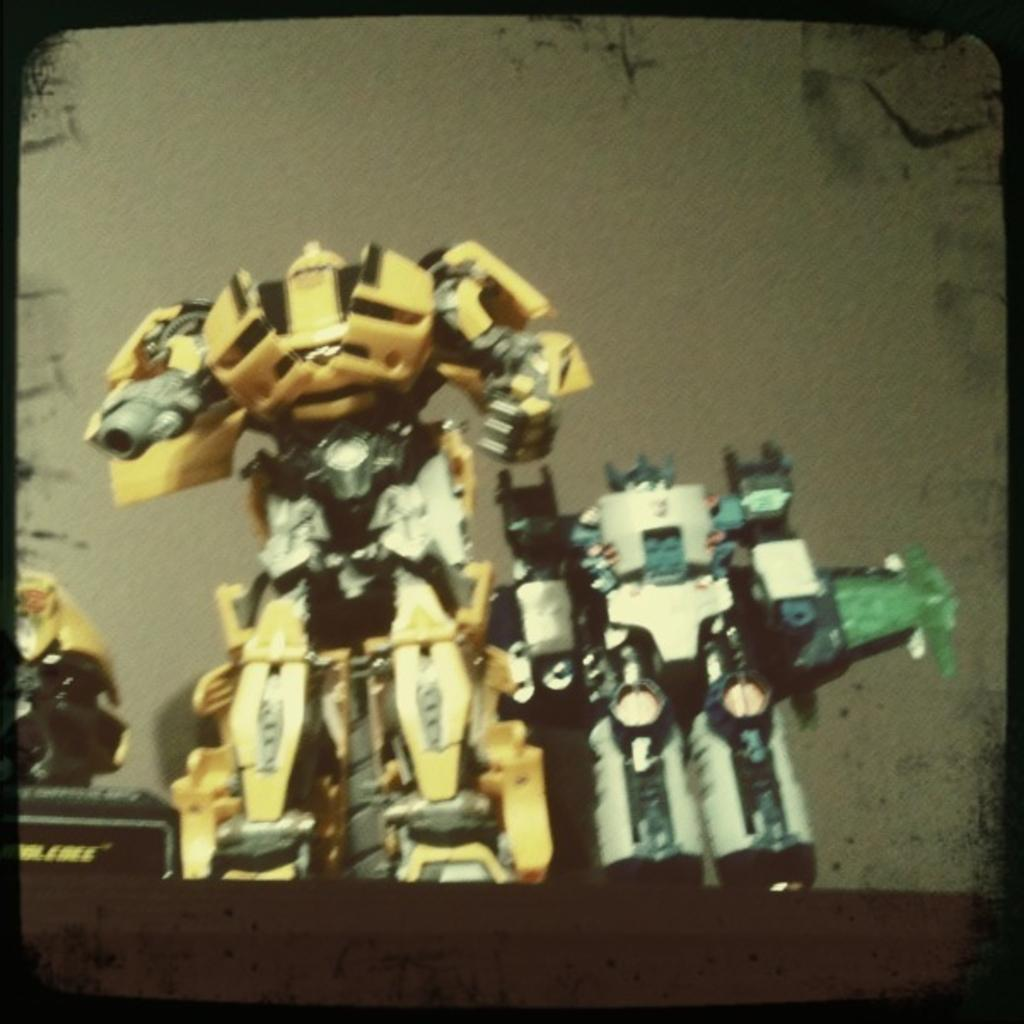What type of toys are present in the image? There are toy robots in the image. Can you describe the color or lighting at the bottom of the image? The bottom of the image is dark. What type of care is being provided to the oranges in the image? There are no oranges present in the image, so no care is being provided to them. 